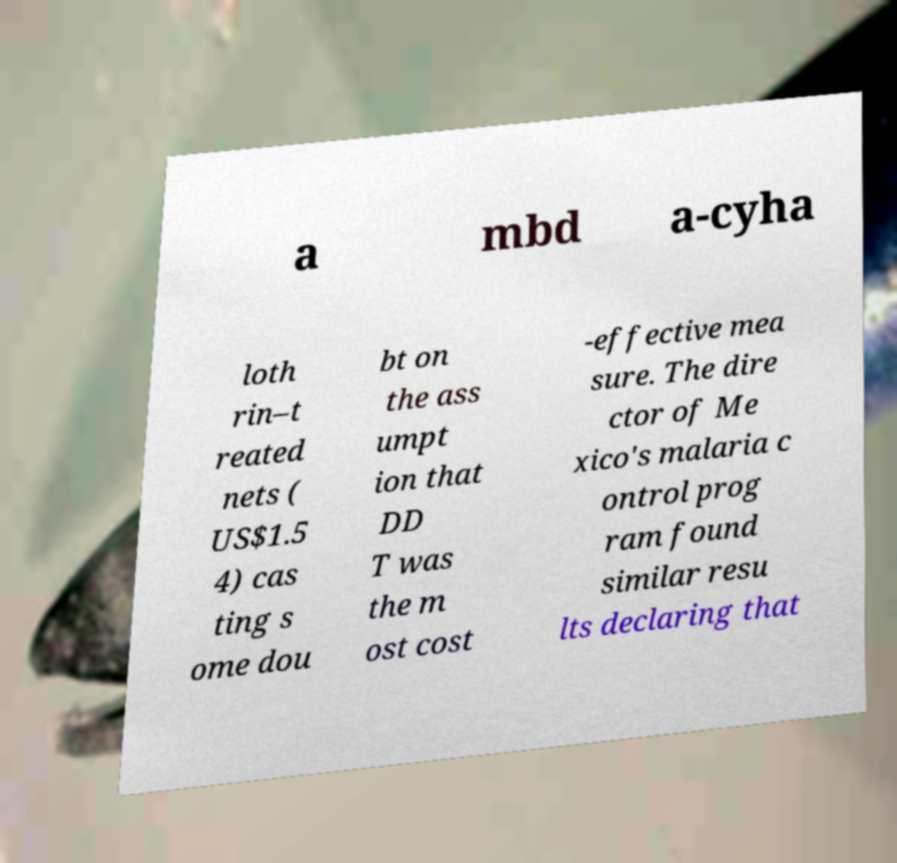Please identify and transcribe the text found in this image. a mbd a-cyha loth rin–t reated nets ( US$1.5 4) cas ting s ome dou bt on the ass umpt ion that DD T was the m ost cost -effective mea sure. The dire ctor of Me xico's malaria c ontrol prog ram found similar resu lts declaring that 